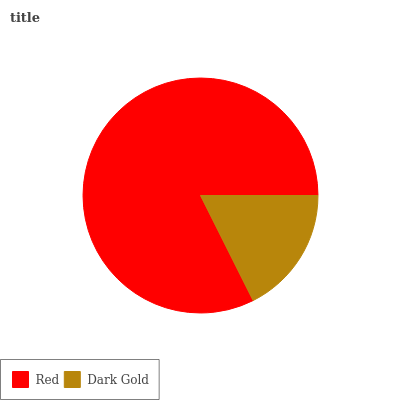Is Dark Gold the minimum?
Answer yes or no. Yes. Is Red the maximum?
Answer yes or no. Yes. Is Dark Gold the maximum?
Answer yes or no. No. Is Red greater than Dark Gold?
Answer yes or no. Yes. Is Dark Gold less than Red?
Answer yes or no. Yes. Is Dark Gold greater than Red?
Answer yes or no. No. Is Red less than Dark Gold?
Answer yes or no. No. Is Red the high median?
Answer yes or no. Yes. Is Dark Gold the low median?
Answer yes or no. Yes. Is Dark Gold the high median?
Answer yes or no. No. Is Red the low median?
Answer yes or no. No. 